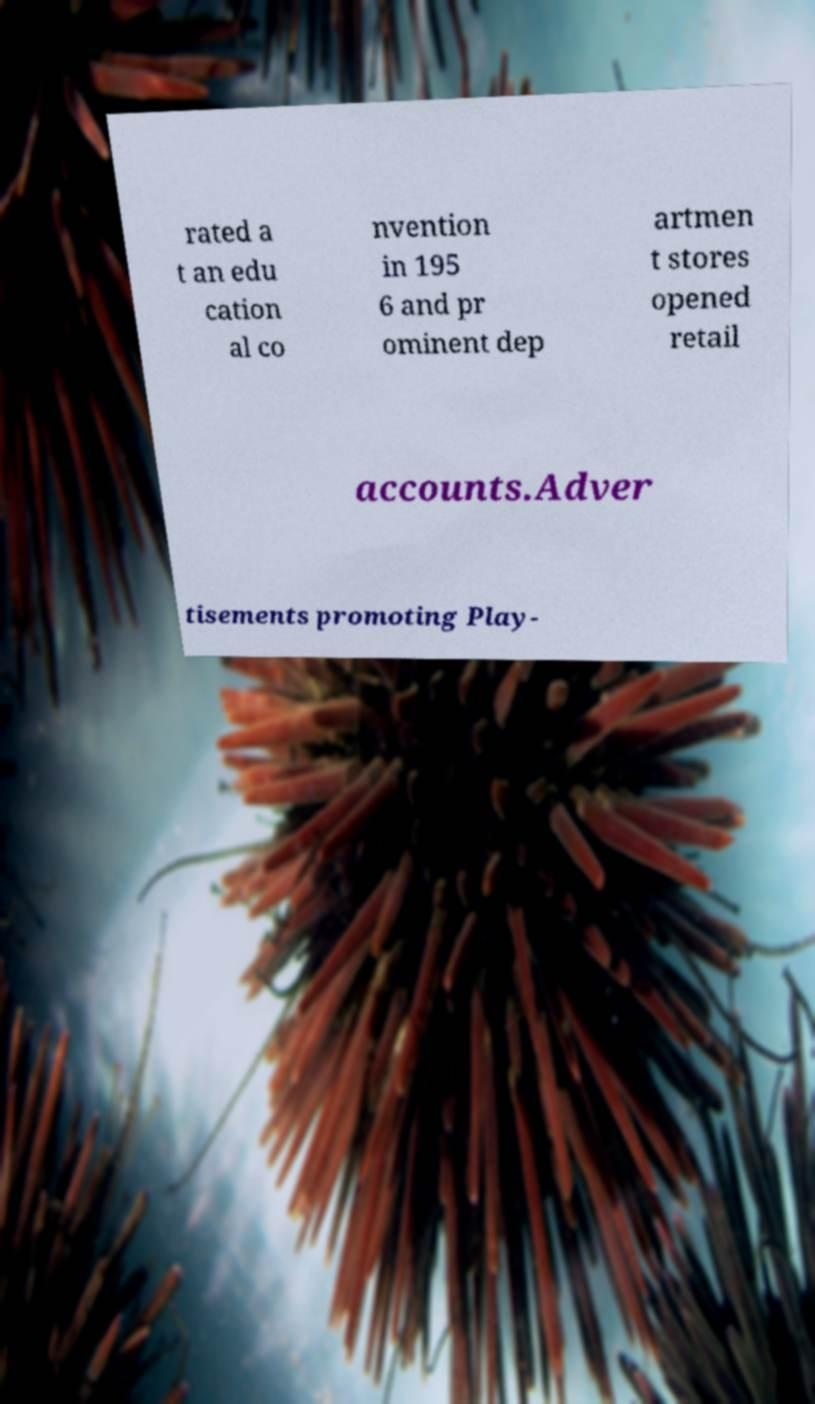Please identify and transcribe the text found in this image. rated a t an edu cation al co nvention in 195 6 and pr ominent dep artmen t stores opened retail accounts.Adver tisements promoting Play- 